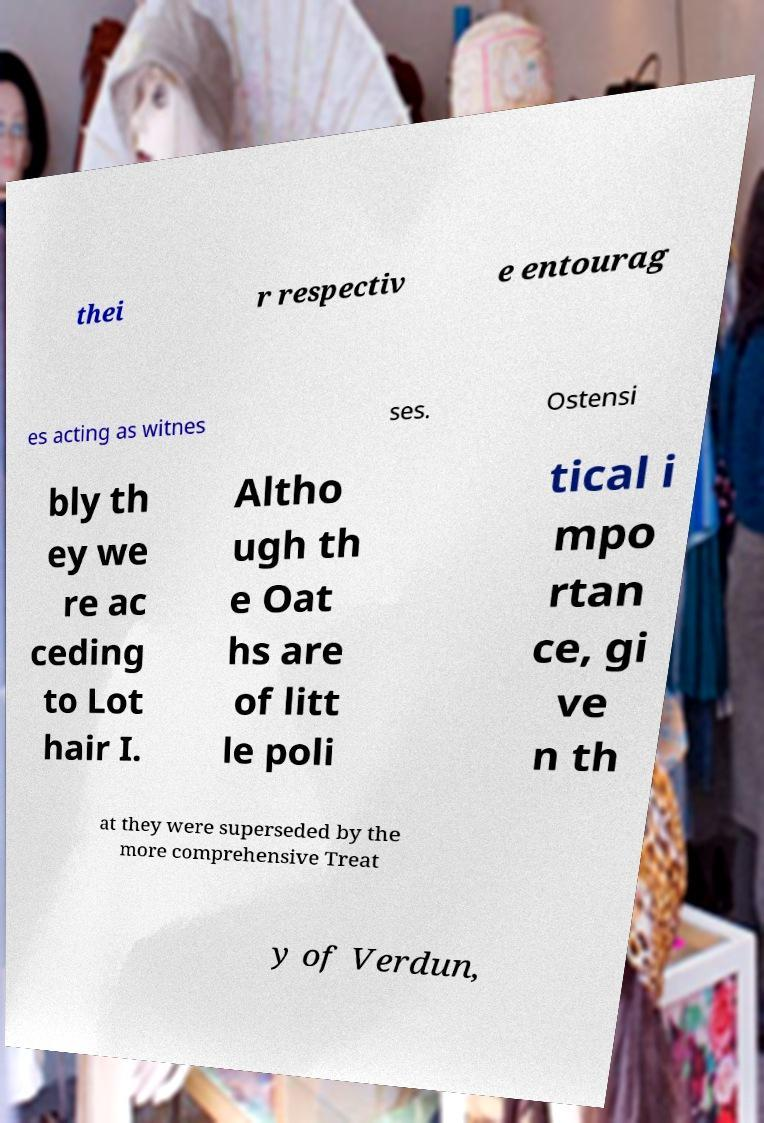There's text embedded in this image that I need extracted. Can you transcribe it verbatim? thei r respectiv e entourag es acting as witnes ses. Ostensi bly th ey we re ac ceding to Lot hair I. Altho ugh th e Oat hs are of litt le poli tical i mpo rtan ce, gi ve n th at they were superseded by the more comprehensive Treat y of Verdun, 